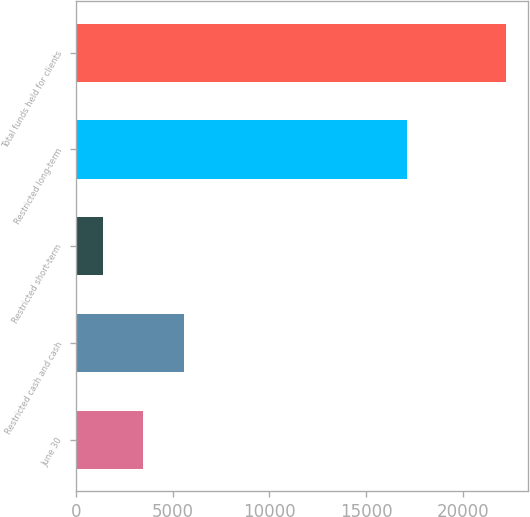Convert chart. <chart><loc_0><loc_0><loc_500><loc_500><bar_chart><fcel>June 30<fcel>Restricted cash and cash<fcel>Restricted short-term<fcel>Restricted long-term<fcel>Total funds held for clients<nl><fcel>3489.81<fcel>5571.92<fcel>1407.7<fcel>17089<fcel>22228.8<nl></chart> 